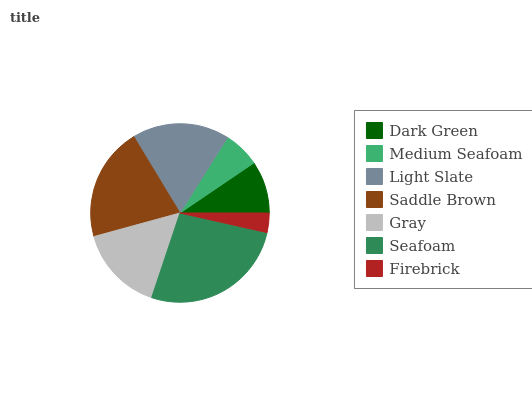Is Firebrick the minimum?
Answer yes or no. Yes. Is Seafoam the maximum?
Answer yes or no. Yes. Is Medium Seafoam the minimum?
Answer yes or no. No. Is Medium Seafoam the maximum?
Answer yes or no. No. Is Dark Green greater than Medium Seafoam?
Answer yes or no. Yes. Is Medium Seafoam less than Dark Green?
Answer yes or no. Yes. Is Medium Seafoam greater than Dark Green?
Answer yes or no. No. Is Dark Green less than Medium Seafoam?
Answer yes or no. No. Is Gray the high median?
Answer yes or no. Yes. Is Gray the low median?
Answer yes or no. Yes. Is Medium Seafoam the high median?
Answer yes or no. No. Is Saddle Brown the low median?
Answer yes or no. No. 